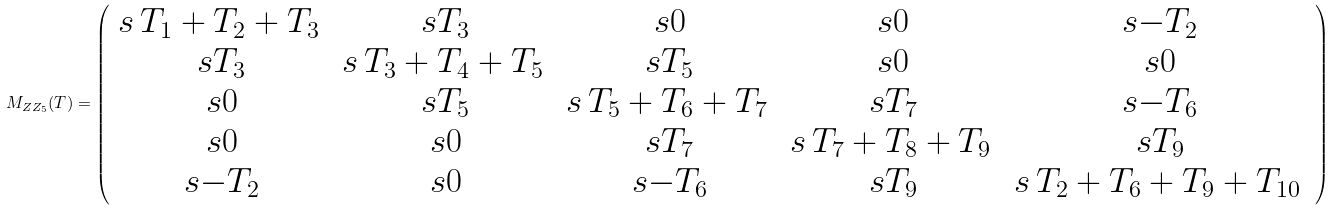Convert formula to latex. <formula><loc_0><loc_0><loc_500><loc_500>M _ { Z Z _ { 5 } } ( T ) = \left ( \begin{array} { c c c c c } s { \, T _ { 1 } + T _ { 2 } + T _ { 3 } \, } & s { T _ { 3 } } & s { 0 } & s { 0 } & s { - T _ { 2 } } \\ s { T _ { 3 } } & s { \, T _ { 3 } + T _ { 4 } + T _ { 5 } \, } & s { T _ { 5 } } & s { 0 } & s { 0 } \\ s { 0 } & s { T _ { 5 } } & s { \, T _ { 5 } + T _ { 6 } + T _ { 7 } \, } & s { T _ { 7 } } & s { - T _ { 6 } } \\ s { 0 } & s { 0 } & s { T _ { 7 } } & s { \, T _ { 7 } + T _ { 8 } + T _ { 9 } \, } & s { T _ { 9 } } \\ s { - T _ { 2 } } & s { 0 } & s { - T _ { 6 } } & s { T _ { 9 } } & s { \, T _ { 2 } + T _ { 6 } + T _ { 9 } + T _ { 1 0 } \, } \\ \end{array} \right )</formula> 